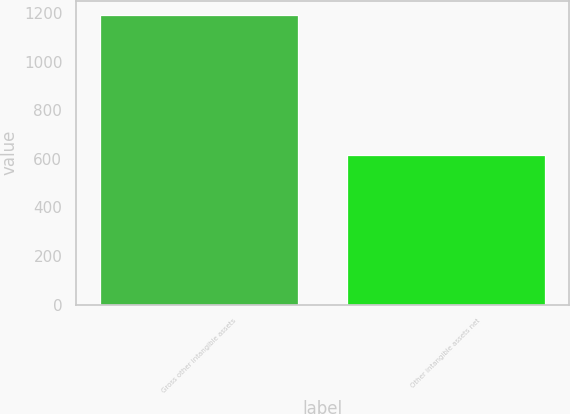<chart> <loc_0><loc_0><loc_500><loc_500><bar_chart><fcel>Gross other intangible assets<fcel>Other intangible assets net<nl><fcel>1192<fcel>614<nl></chart> 